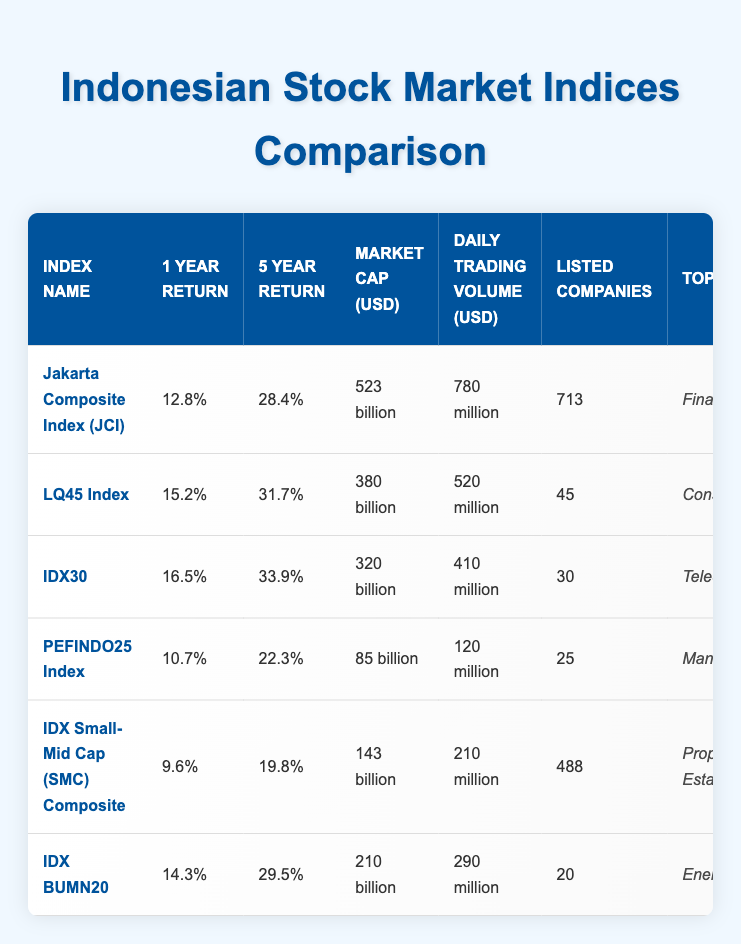What is the highest 1-year return among the indices? The table lists the 1-year returns for each index. Scanning through the values, IDX30 has the highest return at 16.5%.
Answer: 16.5% How many listed companies are there in the LQ45 Index? The table provides the number of listed companies for each index. For the LQ45 Index, it shows there are 45 listed companies.
Answer: 45 Which index has the lowest 5-year return? To find the lowest 5-year return, we look at the 5-year return values in the table. IDX Small-Mid Cap (SMC) Composite has the lowest return at 19.8%.
Answer: 19.8% What is the combined market capitalization of the IDX30 and IDX BUMN20? The table shows the market cap values: IDX30 is 320 billion and IDX BUMN20 is 210 billion. Adding these gives 320 billion + 210 billion = 530 billion.
Answer: 530 billion Is the top sector for the Jakarta Composite Index (JCI) Financials? Referring to the table, it states that the top sector for JCI is indeed Financials.
Answer: Yes Which index has the highest daily trading volume? By examining the daily trading volume column, we see that the Jakarta Composite Index (JCI) has the highest at 780 million.
Answer: 780 million What is the average 1-year return of the top three performing indices? The top three performers in the 1-year return are IDX30 (16.5%), LQ45 (15.2%), and JCI (12.8%). Their average is calculated as (16.5 + 15.2 + 12.8) / 3 = 14.5%.
Answer: 14.5% Do indices with more listed companies generally have lower returns? While examining the data, we see that both JCI and IDX Small-Mid Cap have the highest and lowest returns respectively, yet JCI has 713 listed companies while IDX Small-Mid Cap has 488. Since majority of the high-performing indices (like IDX30 and LQ45) have fewer companies, this suggests a potential inverse relationship, but further analysis is needed to confirm this.
Answer: No What is the percentage difference in market capitalization between the LQ45 Index and PEFINDO25 Index? The market cap for LQ45 Index is 380 billion, and for PEFINDO25 Index, it is 85 billion. The difference is calculated as (380 - 85) billion = 295 billion, and the percentage difference can be found by (295 / 380) * 100 = 77.37%.
Answer: 77.37% 